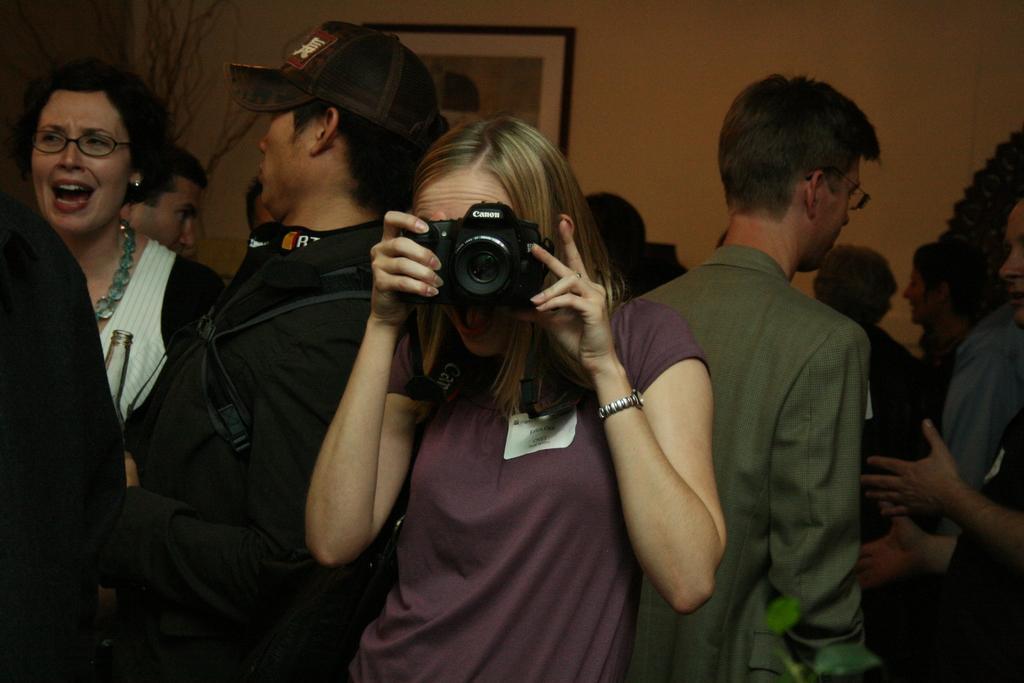Could you give a brief overview of what you see in this image? In the image we can see there are lot of people who are standing and in front there is woman holding a camera in her hand. 